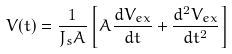<formula> <loc_0><loc_0><loc_500><loc_500>V ( t ) = \frac { 1 } { J _ { s } A } \left [ A \frac { d V _ { e x } } { d t } + \frac { d ^ { 2 } V _ { e x } } { d t ^ { 2 } } \right ]</formula> 